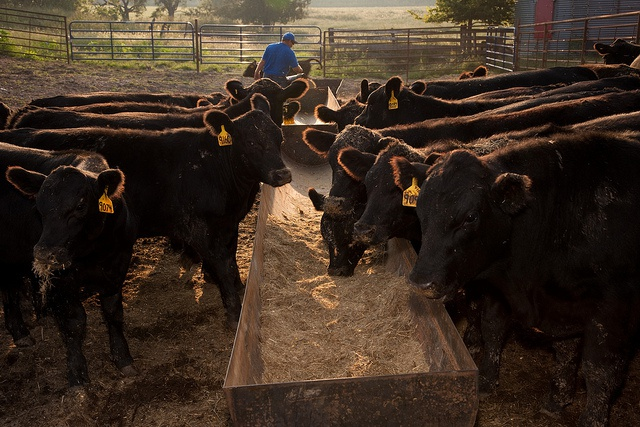Describe the objects in this image and their specific colors. I can see cow in black, maroon, and brown tones, cow in black, maroon, and gray tones, cow in black, maroon, and gray tones, cow in black, maroon, and brown tones, and cow in black, maroon, and gray tones in this image. 